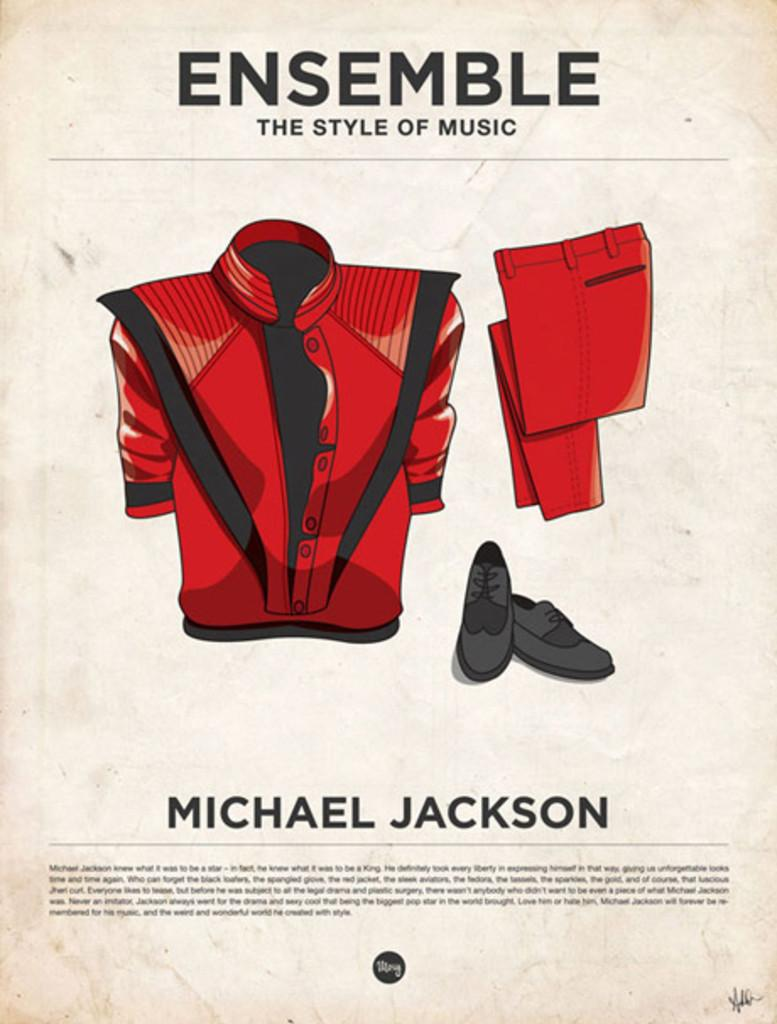What is the main object in the image? There is a poster in the image. What else can be seen in the image besides the poster? Clothing items are visible in the image. What is written or depicted on the poster? There is text on the poster. What type of doll is sitting on the produce in the image? There is no doll or produce present in the image; it only features a poster and clothing items. 